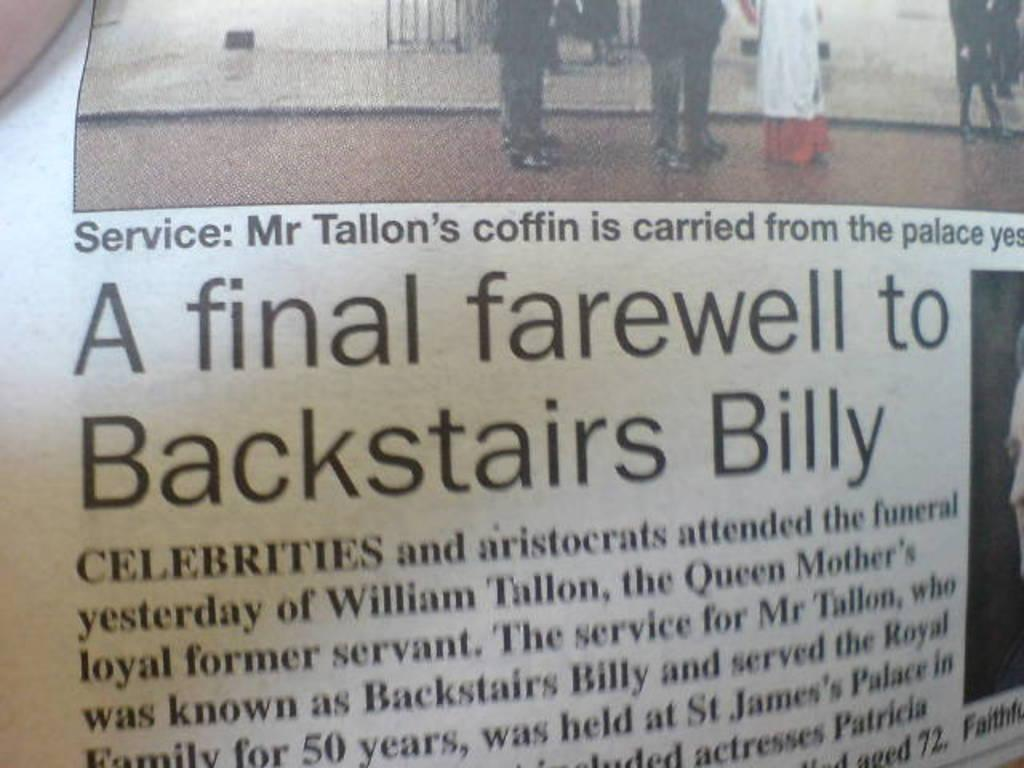What is present in the image that contains both text and images? There is a poster in the image that contains text and images. Can you describe the content of the poster? The poster contains text and images, but the specific content cannot be determined from the provided facts. Where is the monkey sitting on the floor in the image? There is no monkey present in the image. What is your brother doing in the image? There is no reference to a brother in the provided facts, so it cannot be determined if a brother is present in the image. 